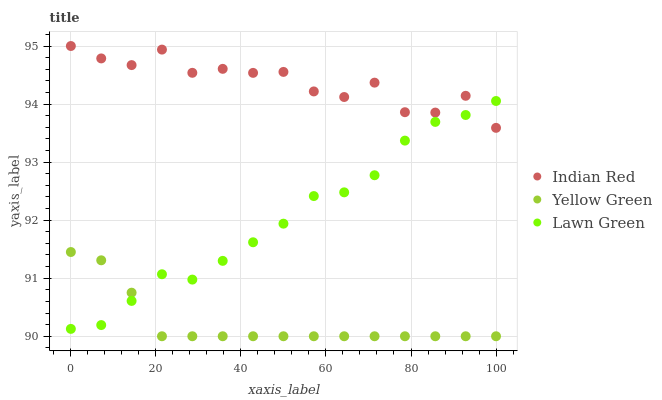Does Yellow Green have the minimum area under the curve?
Answer yes or no. Yes. Does Indian Red have the maximum area under the curve?
Answer yes or no. Yes. Does Indian Red have the minimum area under the curve?
Answer yes or no. No. Does Yellow Green have the maximum area under the curve?
Answer yes or no. No. Is Yellow Green the smoothest?
Answer yes or no. Yes. Is Indian Red the roughest?
Answer yes or no. Yes. Is Indian Red the smoothest?
Answer yes or no. No. Is Yellow Green the roughest?
Answer yes or no. No. Does Yellow Green have the lowest value?
Answer yes or no. Yes. Does Indian Red have the lowest value?
Answer yes or no. No. Does Indian Red have the highest value?
Answer yes or no. Yes. Does Yellow Green have the highest value?
Answer yes or no. No. Is Yellow Green less than Indian Red?
Answer yes or no. Yes. Is Indian Red greater than Yellow Green?
Answer yes or no. Yes. Does Lawn Green intersect Yellow Green?
Answer yes or no. Yes. Is Lawn Green less than Yellow Green?
Answer yes or no. No. Is Lawn Green greater than Yellow Green?
Answer yes or no. No. Does Yellow Green intersect Indian Red?
Answer yes or no. No. 